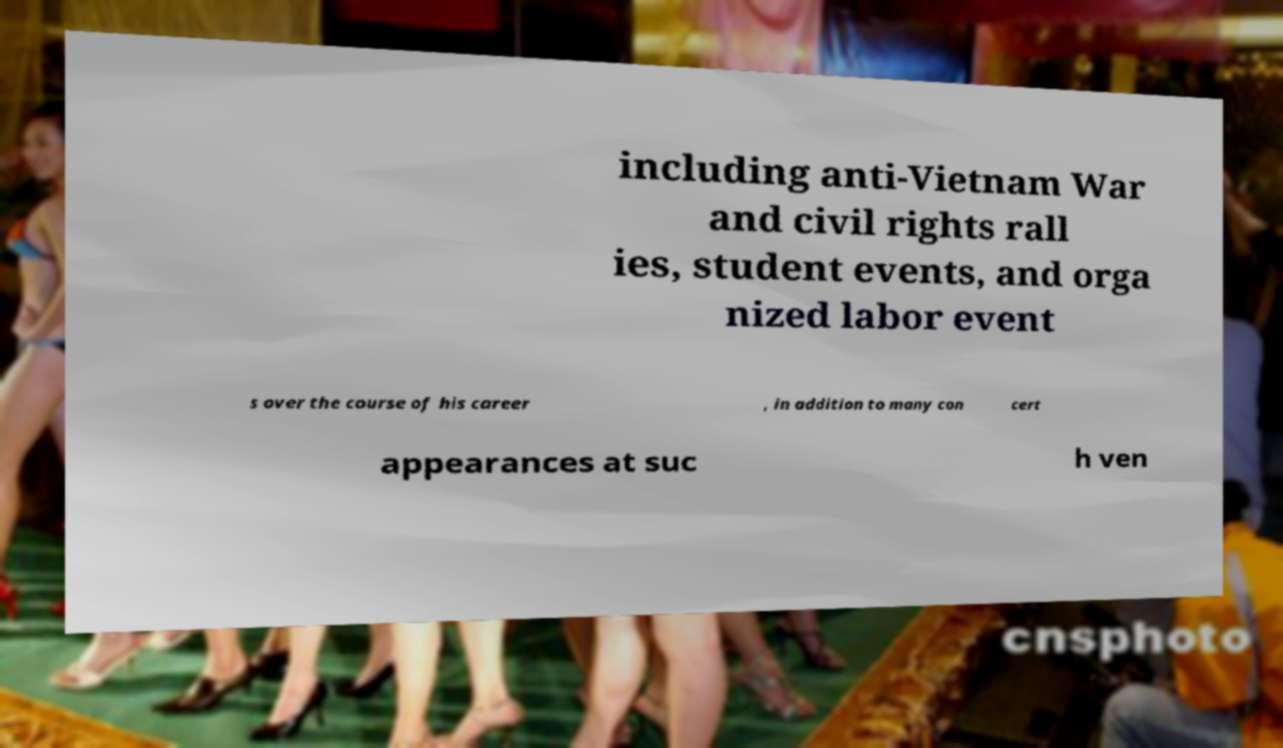For documentation purposes, I need the text within this image transcribed. Could you provide that? including anti-Vietnam War and civil rights rall ies, student events, and orga nized labor event s over the course of his career , in addition to many con cert appearances at suc h ven 